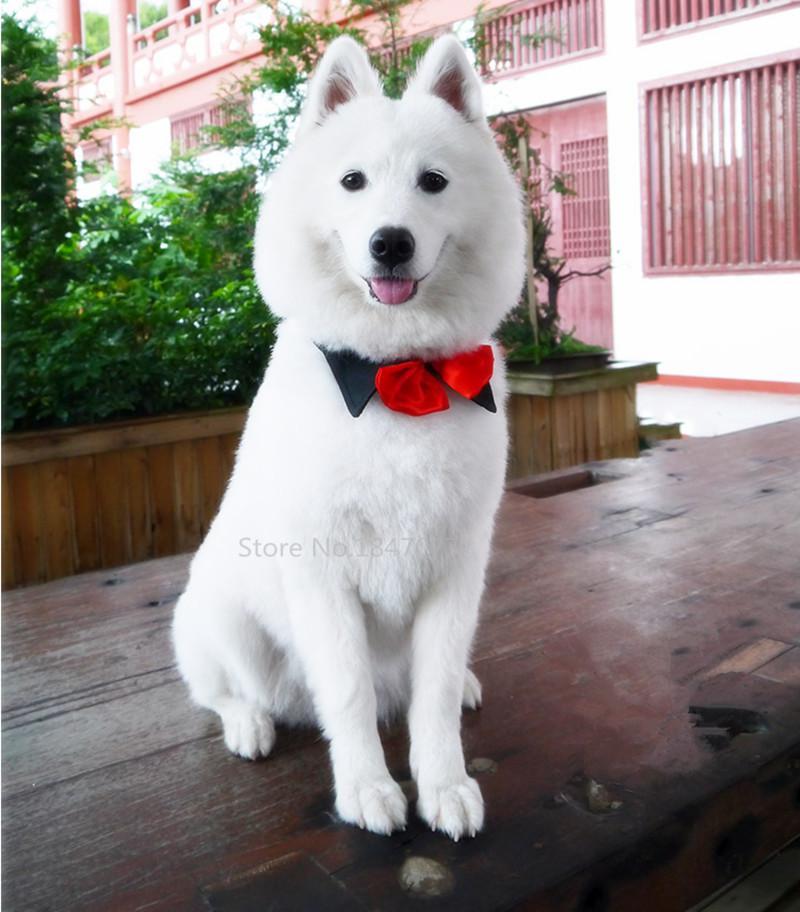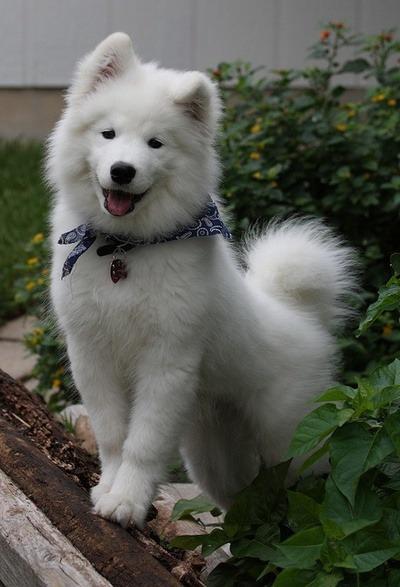The first image is the image on the left, the second image is the image on the right. Examine the images to the left and right. Is the description "Each image contains exactly one fluffy dog." accurate? Answer yes or no. Yes. The first image is the image on the left, the second image is the image on the right. Assess this claim about the two images: "Both images contain a single dog.". Correct or not? Answer yes or no. Yes. 